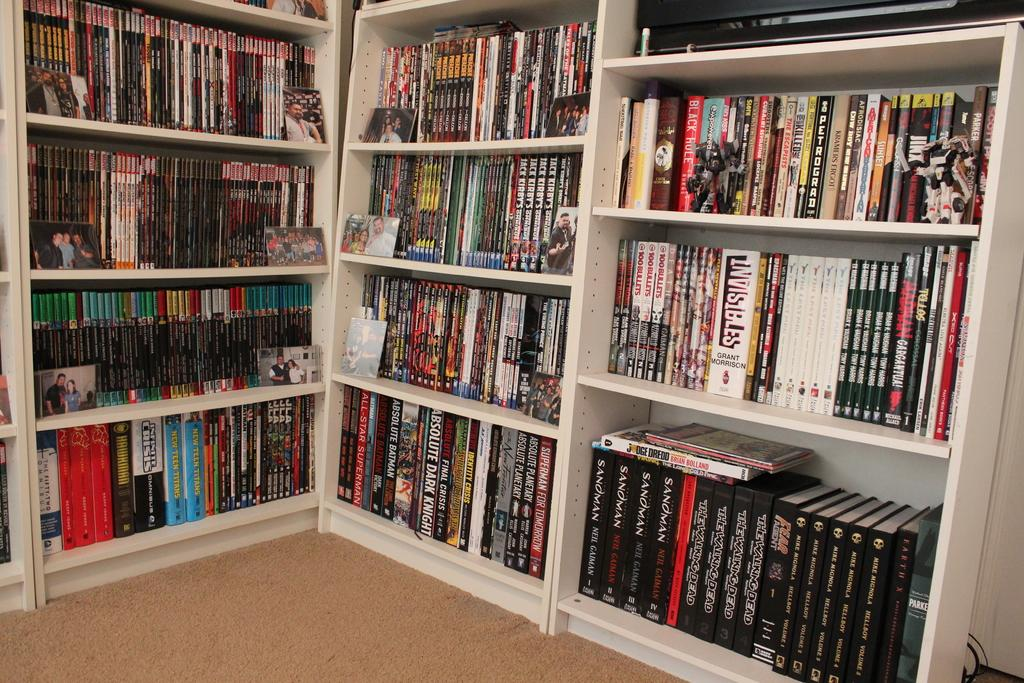<image>
Give a short and clear explanation of the subsequent image. a group of books arranged in racks and one of them named Grand morrison 